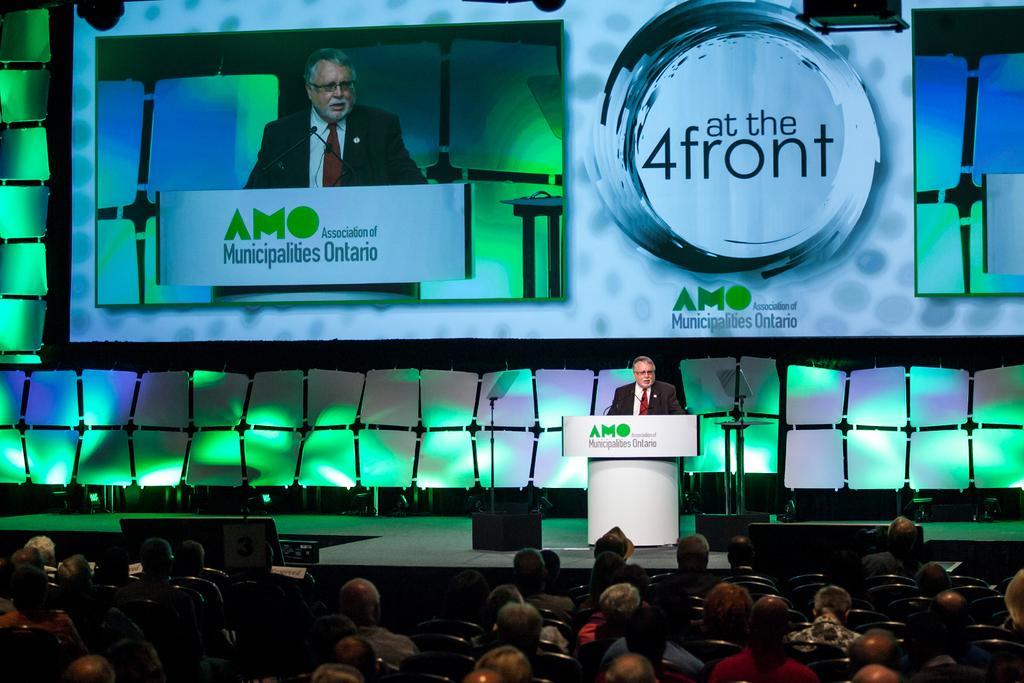Please provide a concise description of this image. There are group of people sitting on chairs and this man standing on stage. We can see podium. In the background we can see screen. 